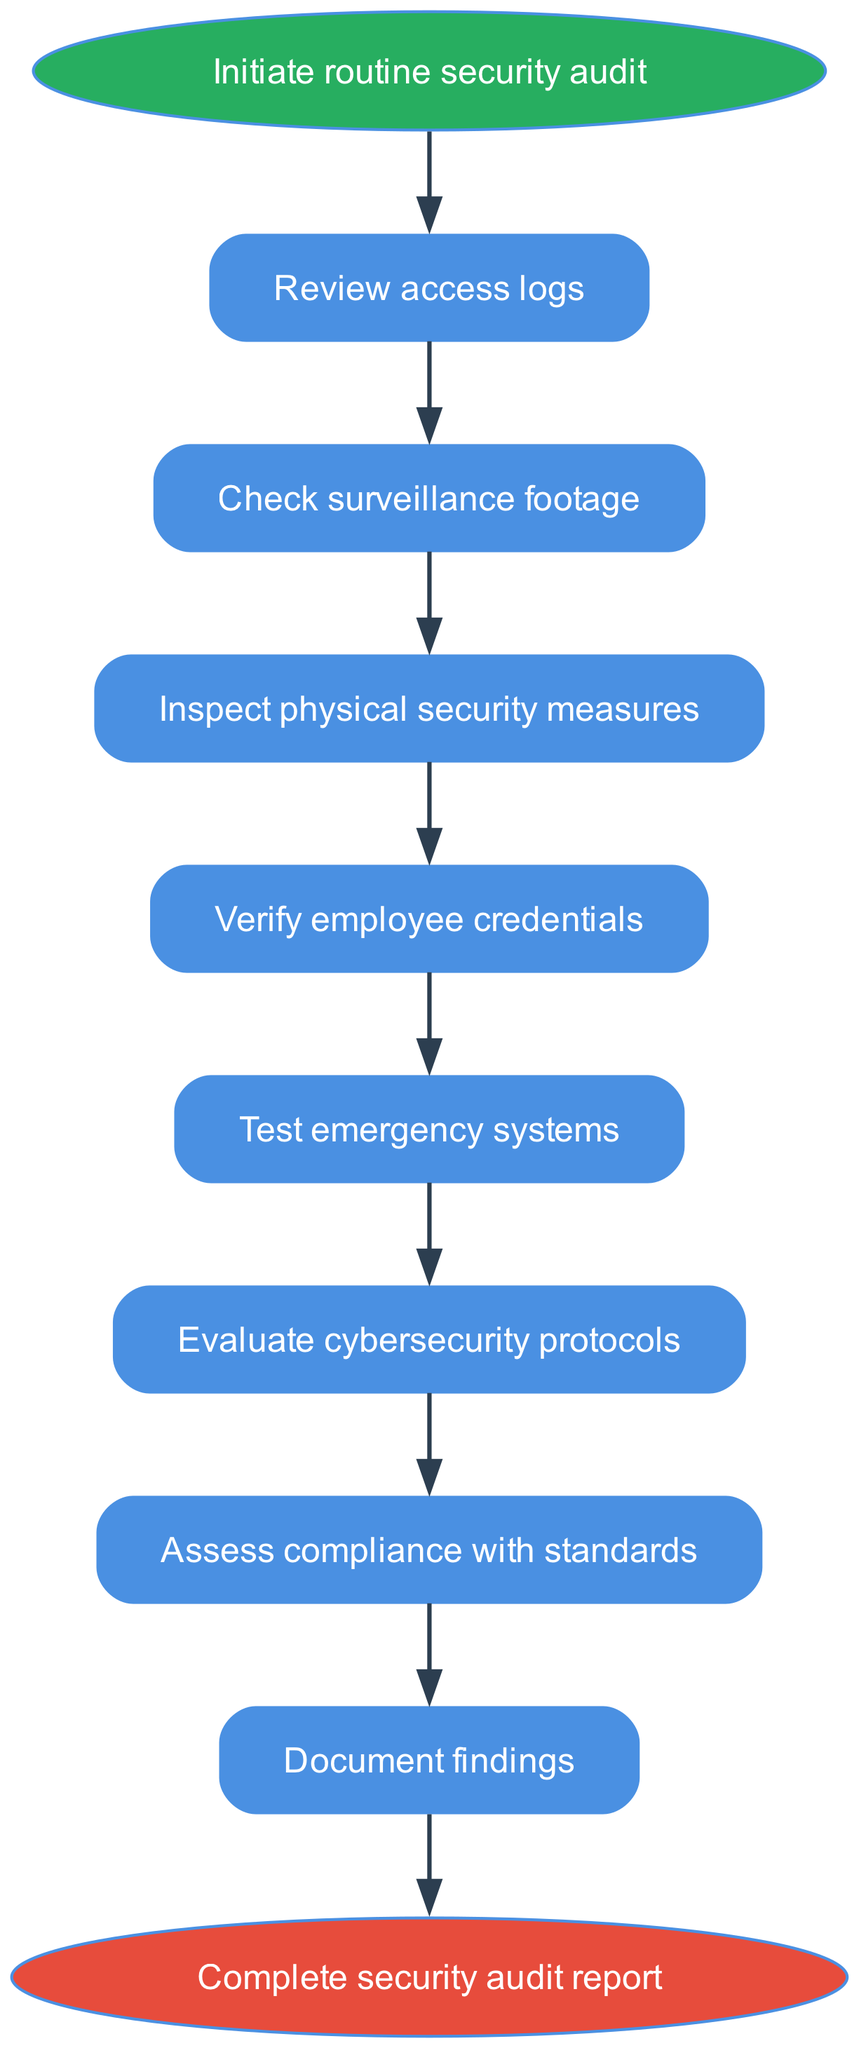What is the first step in the routine security audit process? The first step is labeled as "Initiate routine security audit" in the diagram, indicating that this action starts the entire process.
Answer: Initiate routine security audit How many steps are there in the routine security audit process? The diagram lists eight steps in the routine security audit process from reviewing access logs to documenting findings, before completing the audit report.
Answer: Eight steps What is the last action to be taken in the audit process? The last action is depicted as "Complete security audit report," which indicates the conclusion of the auditing activities outlined in the flow chart.
Answer: Complete security audit report Which step comes after evaluating cybersecurity protocols? Based on the flow, "Assess compliance with standards" follows "Evaluate cybersecurity protocols," indicating the next check in the process.
Answer: Assess compliance with standards What is the relationship between 'Check surveillance footage' and 'Inspect physical security measures'? 'Check surveillance footage' directly leads into 'Inspect physical security measures,' showing a sequential process where one step must follow the other in the timeline of the audit.
Answer: Sequential What is the total number of edges represented in the diagram? There are a total of nine edges connecting the eight steps and the start and end nodes in the flowchart, representing the pathway through the process from start to finish.
Answer: Nine edges What must be done before testing emergency systems? "Verify employee credentials" is the necessary step to be completed prior to "Test emergency systems," indicating that this verification is a prerequisite for the following action in the audit process.
Answer: Verify employee credentials How many nodes consist of physical security measures? The flowchart contains one specific node titled "Inspect physical security measures," identifying it as the unique representation of physical security audits.
Answer: One node What step involves documentation in the security audit process? "Document findings" is the step that includes the action of recording all the observations and outcomes after conducting the various security checks during the audit.
Answer: Document findings 